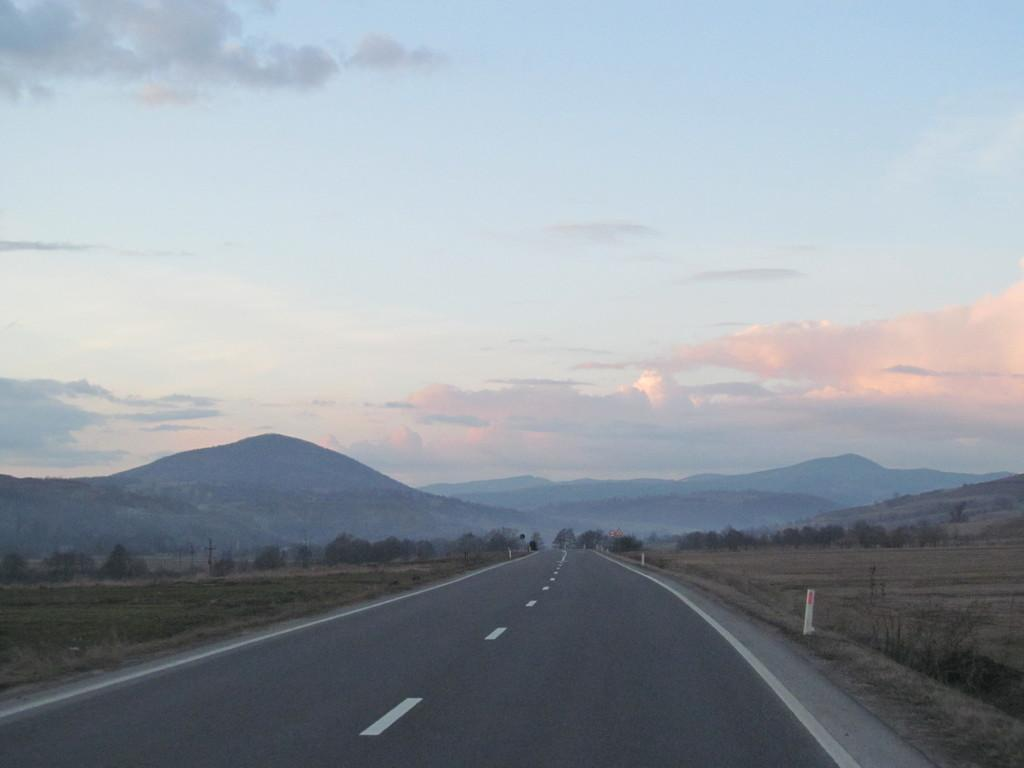What is the main feature of the image? There is a road in the image. What can be seen on the right side of the image? There is a white object visible on the right side of the image. What type of natural scenery is visible in the background of the image? There are trees and mountains in the background of the image. How would you describe the sky in the image? The sky is blue and cloudy in the image. How many women are holding glue in the image? There are no women or glue present in the image. What type of pest can be seen crawling on the road in the image? There are no pests visible in the image; it only features a road, a white object, trees, mountains, and a blue and cloudy sky. 